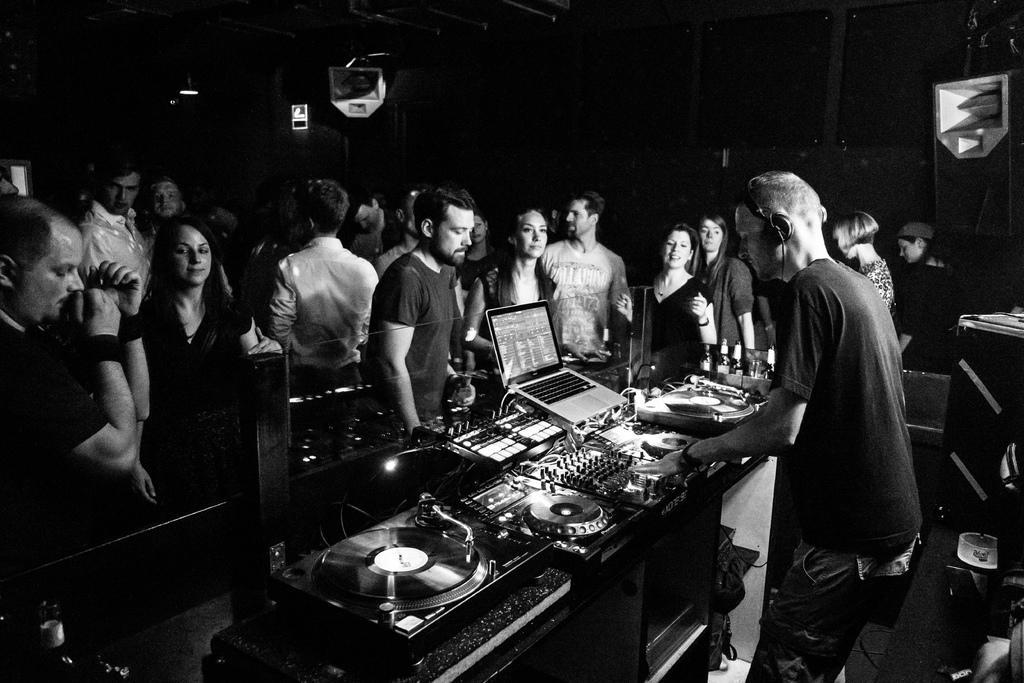Describe this image in one or two sentences. In this picture I can see few people standing and I can see a laptop and few music controlling devices on the table and I can see a man wore a headset and controlling the devices on the table and I can see dark background and couple of bottles on the bottom left corner of the picture. 